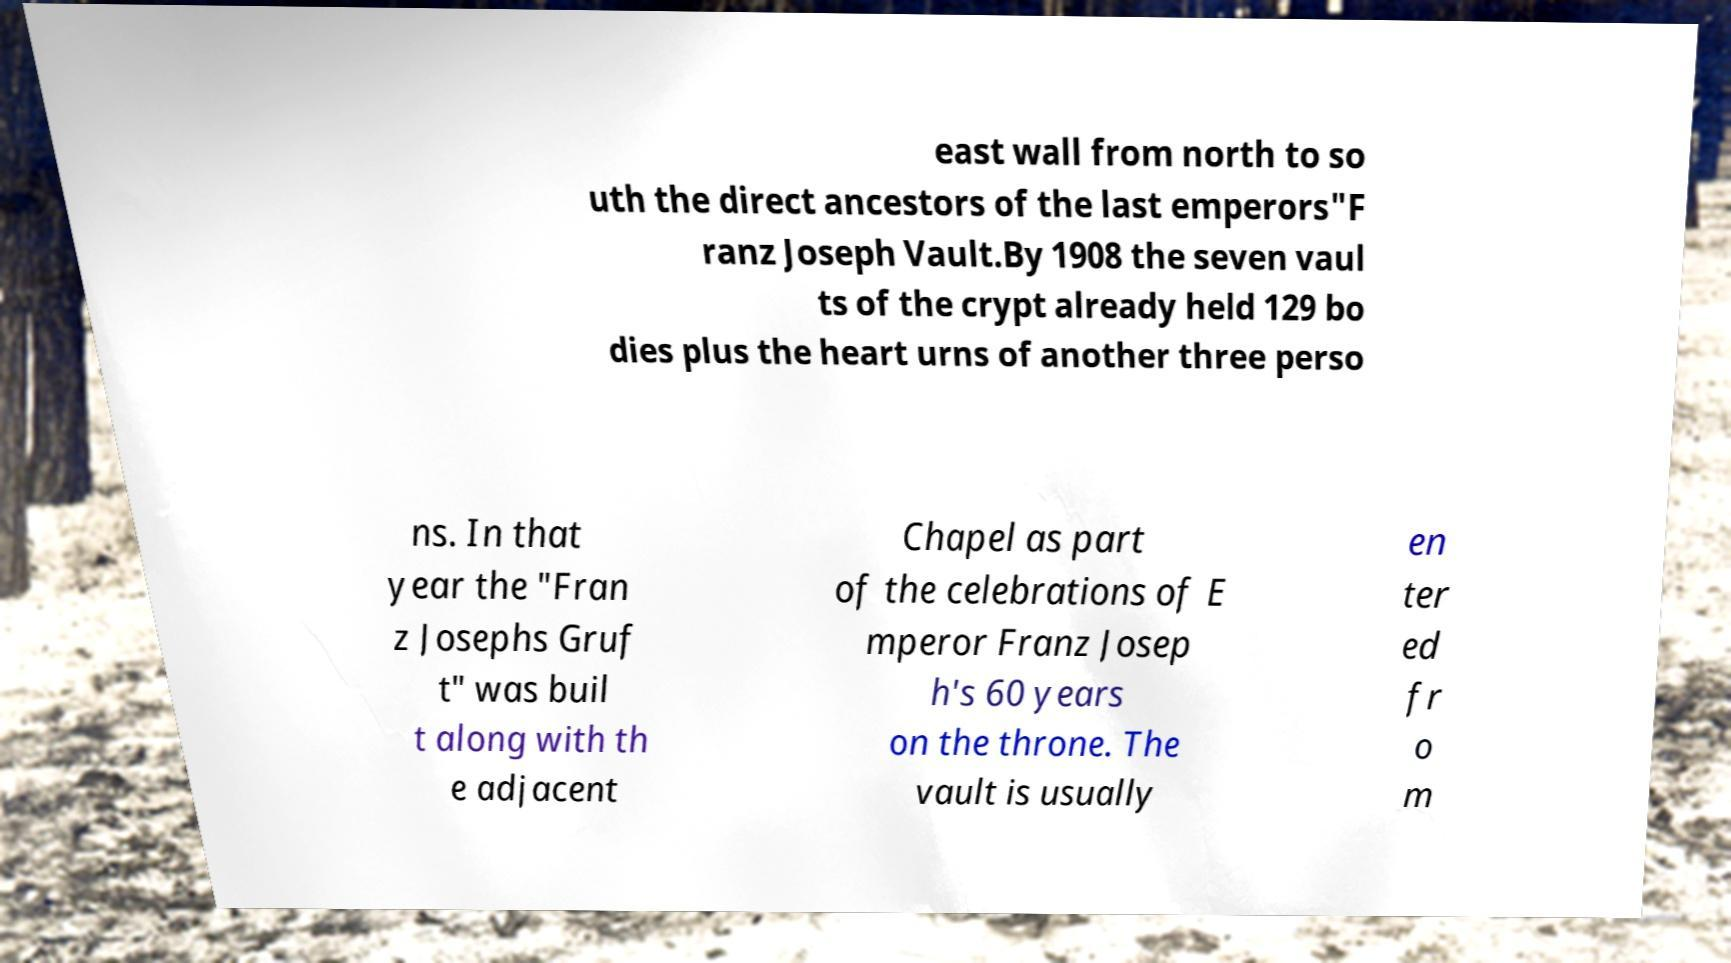For documentation purposes, I need the text within this image transcribed. Could you provide that? east wall from north to so uth the direct ancestors of the last emperors"F ranz Joseph Vault.By 1908 the seven vaul ts of the crypt already held 129 bo dies plus the heart urns of another three perso ns. In that year the "Fran z Josephs Gruf t" was buil t along with th e adjacent Chapel as part of the celebrations of E mperor Franz Josep h's 60 years on the throne. The vault is usually en ter ed fr o m 